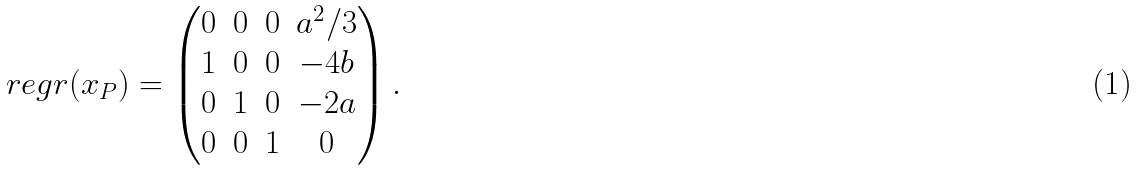<formula> <loc_0><loc_0><loc_500><loc_500>\ r e g r ( x _ { P } ) = \begin{pmatrix} 0 & 0 & 0 & a ^ { 2 } / 3 \\ 1 & 0 & 0 & - 4 b \\ 0 & 1 & 0 & - 2 a \\ 0 & 0 & 1 & 0 \end{pmatrix} .</formula> 